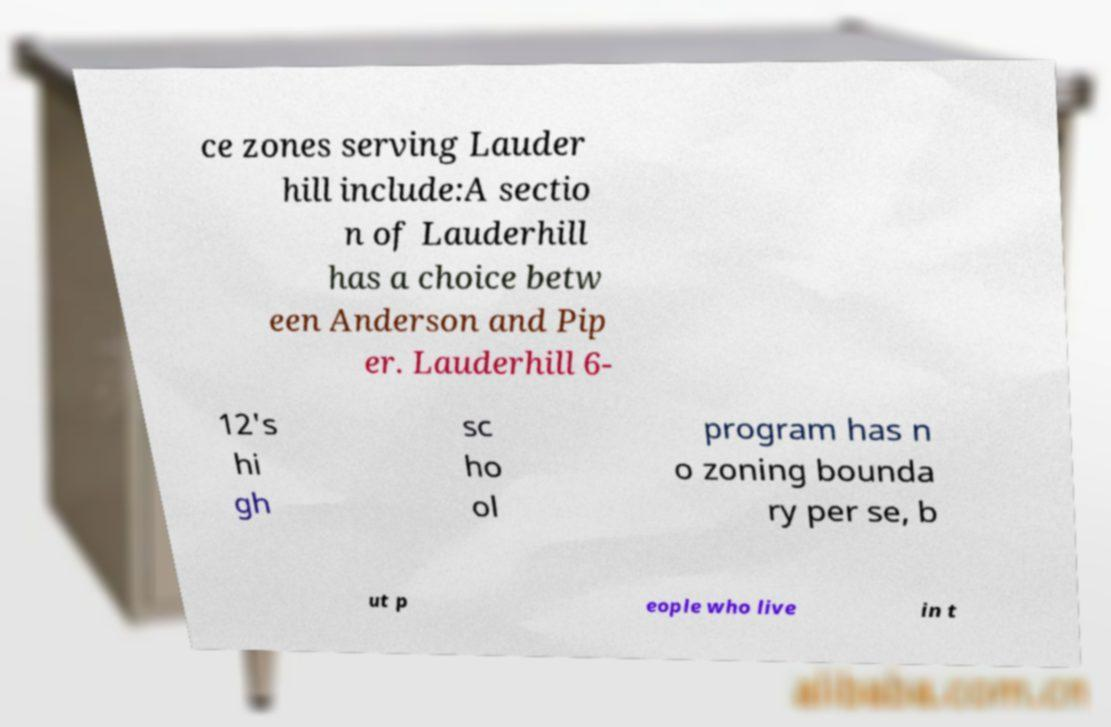There's text embedded in this image that I need extracted. Can you transcribe it verbatim? ce zones serving Lauder hill include:A sectio n of Lauderhill has a choice betw een Anderson and Pip er. Lauderhill 6- 12's hi gh sc ho ol program has n o zoning bounda ry per se, b ut p eople who live in t 